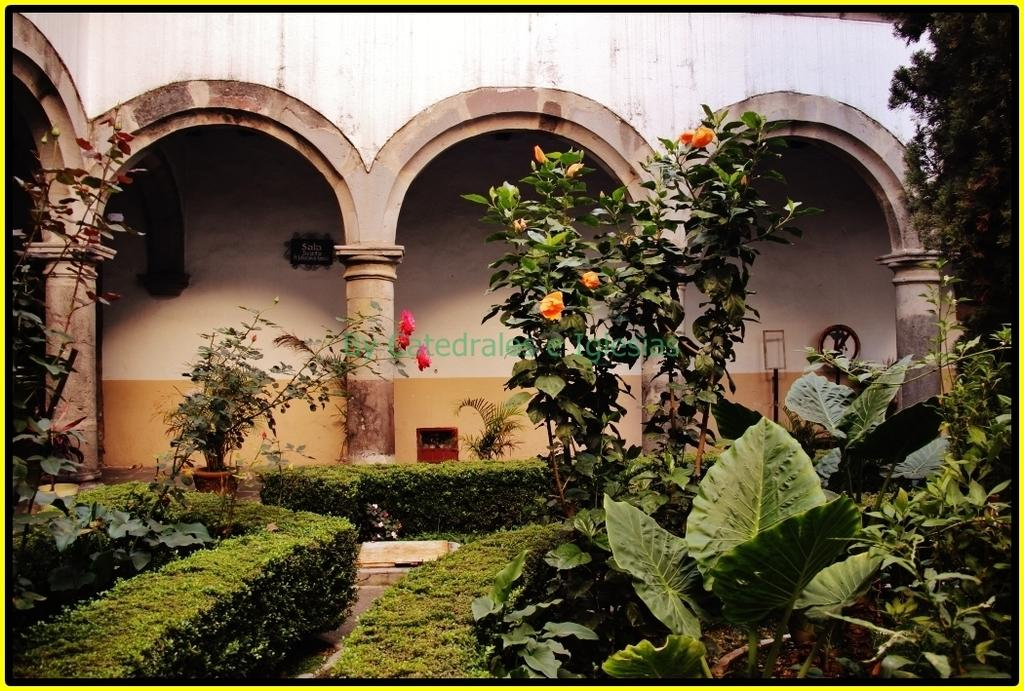What type of living organisms can be seen in the image? Plants and flowers are visible in the image. What architectural features are present in the image? There is a wall and pillars in the image. Can you describe any other objects in the image? Yes, there are some objects in the image. How many ants are crawling on the can in the image? There is no can present in the image, and therefore no ants can be observed. 